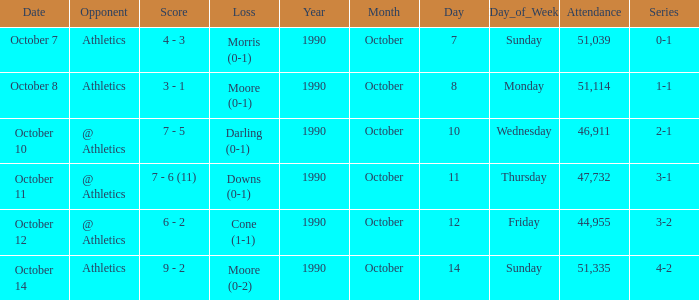When was the game with the loss of Moore (0-1)? October 8. 